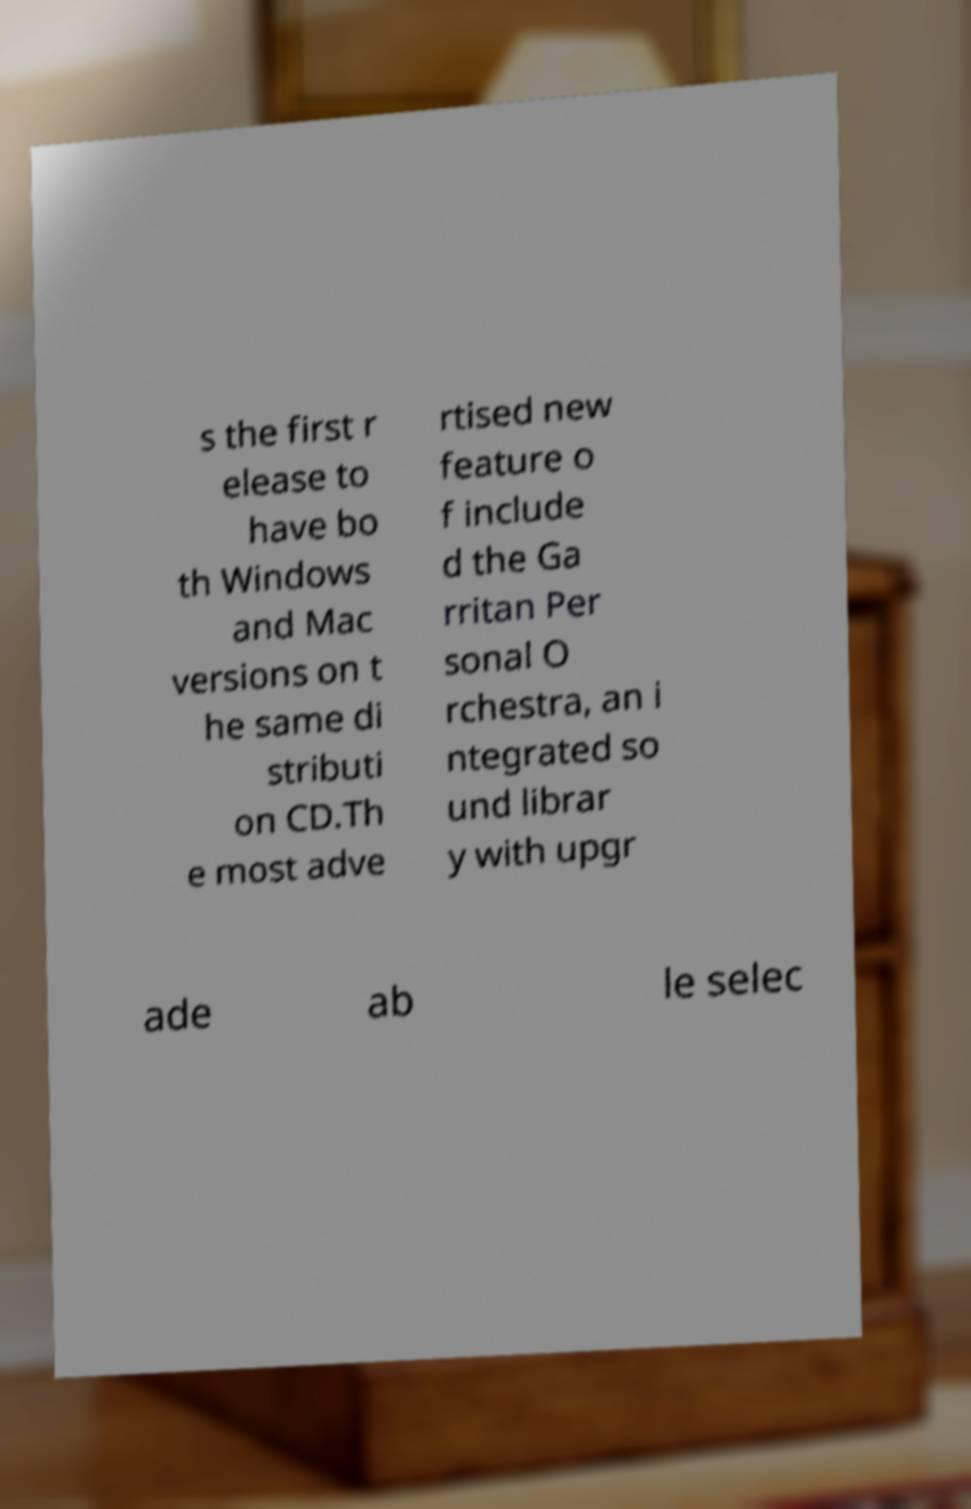Can you accurately transcribe the text from the provided image for me? s the first r elease to have bo th Windows and Mac versions on t he same di stributi on CD.Th e most adve rtised new feature o f include d the Ga rritan Per sonal O rchestra, an i ntegrated so und librar y with upgr ade ab le selec 